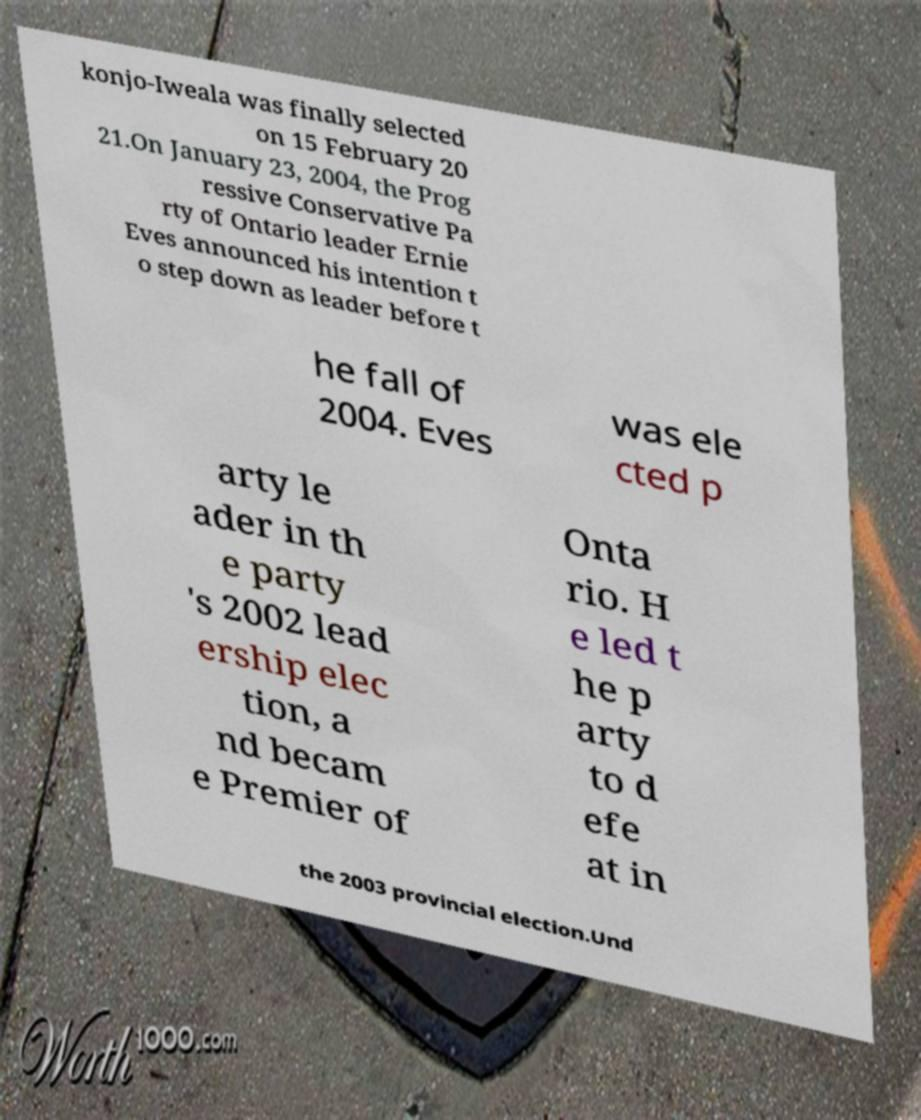Could you assist in decoding the text presented in this image and type it out clearly? konjo-Iweala was finally selected on 15 February 20 21.On January 23, 2004, the Prog ressive Conservative Pa rty of Ontario leader Ernie Eves announced his intention t o step down as leader before t he fall of 2004. Eves was ele cted p arty le ader in th e party 's 2002 lead ership elec tion, a nd becam e Premier of Onta rio. H e led t he p arty to d efe at in the 2003 provincial election.Und 